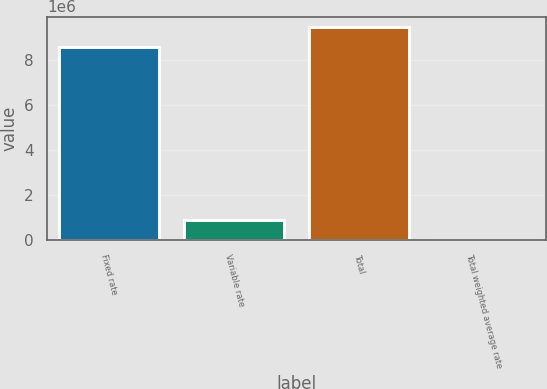<chart> <loc_0><loc_0><loc_500><loc_500><bar_chart><fcel>Fixed rate<fcel>Variable rate<fcel>Total<fcel>Total weighted average rate<nl><fcel>8.60608e+06<fcel>864651<fcel>9.47072e+06<fcel>5.22<nl></chart> 